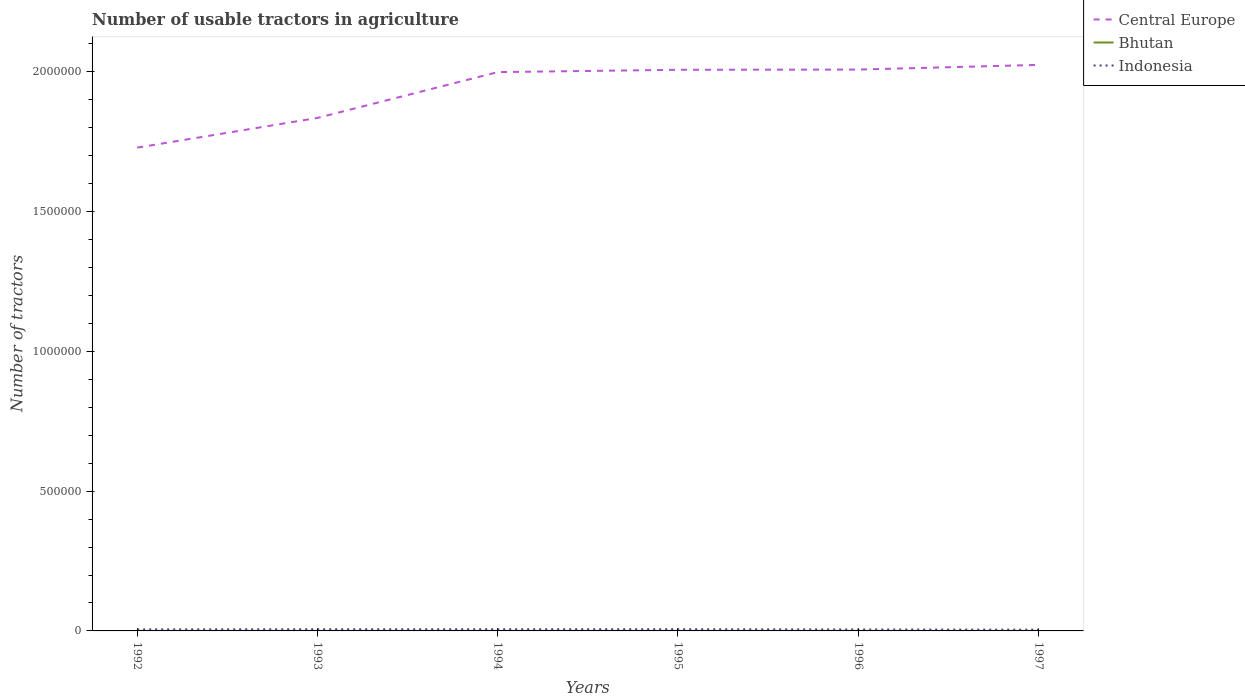How many different coloured lines are there?
Keep it short and to the point. 3. Is the number of lines equal to the number of legend labels?
Your answer should be compact. Yes. Across all years, what is the maximum number of usable tractors in agriculture in Indonesia?
Give a very brief answer. 4483. What is the total number of usable tractors in agriculture in Central Europe in the graph?
Keep it short and to the point. -1.06e+05. What is the difference between the highest and the second highest number of usable tractors in agriculture in Indonesia?
Offer a terse response. 1641. Is the number of usable tractors in agriculture in Indonesia strictly greater than the number of usable tractors in agriculture in Central Europe over the years?
Offer a very short reply. Yes. How many lines are there?
Give a very brief answer. 3. What is the title of the graph?
Make the answer very short. Number of usable tractors in agriculture. What is the label or title of the X-axis?
Offer a terse response. Years. What is the label or title of the Y-axis?
Offer a very short reply. Number of tractors. What is the Number of tractors in Central Europe in 1992?
Your answer should be compact. 1.73e+06. What is the Number of tractors in Bhutan in 1992?
Make the answer very short. 70. What is the Number of tractors of Indonesia in 1992?
Ensure brevity in your answer.  5470. What is the Number of tractors in Central Europe in 1993?
Offer a terse response. 1.83e+06. What is the Number of tractors in Indonesia in 1993?
Make the answer very short. 5942. What is the Number of tractors of Central Europe in 1994?
Your answer should be compact. 2.00e+06. What is the Number of tractors in Indonesia in 1994?
Give a very brief answer. 6033. What is the Number of tractors in Central Europe in 1995?
Your answer should be compact. 2.01e+06. What is the Number of tractors in Indonesia in 1995?
Offer a very short reply. 6124. What is the Number of tractors of Central Europe in 1996?
Offer a terse response. 2.01e+06. What is the Number of tractors of Bhutan in 1996?
Your answer should be very brief. 106. What is the Number of tractors in Indonesia in 1996?
Offer a terse response. 5139. What is the Number of tractors in Central Europe in 1997?
Your response must be concise. 2.02e+06. What is the Number of tractors of Bhutan in 1997?
Ensure brevity in your answer.  110. What is the Number of tractors of Indonesia in 1997?
Keep it short and to the point. 4483. Across all years, what is the maximum Number of tractors in Central Europe?
Offer a terse response. 2.02e+06. Across all years, what is the maximum Number of tractors in Bhutan?
Make the answer very short. 110. Across all years, what is the maximum Number of tractors in Indonesia?
Ensure brevity in your answer.  6124. Across all years, what is the minimum Number of tractors in Central Europe?
Provide a succinct answer. 1.73e+06. Across all years, what is the minimum Number of tractors in Bhutan?
Your response must be concise. 70. Across all years, what is the minimum Number of tractors of Indonesia?
Provide a short and direct response. 4483. What is the total Number of tractors of Central Europe in the graph?
Keep it short and to the point. 1.16e+07. What is the total Number of tractors in Bhutan in the graph?
Offer a terse response. 556. What is the total Number of tractors in Indonesia in the graph?
Your answer should be compact. 3.32e+04. What is the difference between the Number of tractors of Central Europe in 1992 and that in 1993?
Make the answer very short. -1.06e+05. What is the difference between the Number of tractors in Bhutan in 1992 and that in 1993?
Give a very brief answer. -10. What is the difference between the Number of tractors of Indonesia in 1992 and that in 1993?
Ensure brevity in your answer.  -472. What is the difference between the Number of tractors of Central Europe in 1992 and that in 1994?
Provide a short and direct response. -2.70e+05. What is the difference between the Number of tractors in Bhutan in 1992 and that in 1994?
Provide a succinct answer. -20. What is the difference between the Number of tractors in Indonesia in 1992 and that in 1994?
Ensure brevity in your answer.  -563. What is the difference between the Number of tractors of Central Europe in 1992 and that in 1995?
Offer a very short reply. -2.78e+05. What is the difference between the Number of tractors in Bhutan in 1992 and that in 1995?
Provide a succinct answer. -30. What is the difference between the Number of tractors in Indonesia in 1992 and that in 1995?
Your answer should be compact. -654. What is the difference between the Number of tractors of Central Europe in 1992 and that in 1996?
Give a very brief answer. -2.79e+05. What is the difference between the Number of tractors in Bhutan in 1992 and that in 1996?
Provide a short and direct response. -36. What is the difference between the Number of tractors of Indonesia in 1992 and that in 1996?
Ensure brevity in your answer.  331. What is the difference between the Number of tractors of Central Europe in 1992 and that in 1997?
Offer a very short reply. -2.96e+05. What is the difference between the Number of tractors of Indonesia in 1992 and that in 1997?
Offer a terse response. 987. What is the difference between the Number of tractors of Central Europe in 1993 and that in 1994?
Your answer should be very brief. -1.64e+05. What is the difference between the Number of tractors of Bhutan in 1993 and that in 1994?
Your answer should be compact. -10. What is the difference between the Number of tractors of Indonesia in 1993 and that in 1994?
Provide a succinct answer. -91. What is the difference between the Number of tractors of Central Europe in 1993 and that in 1995?
Your response must be concise. -1.72e+05. What is the difference between the Number of tractors of Indonesia in 1993 and that in 1995?
Keep it short and to the point. -182. What is the difference between the Number of tractors of Central Europe in 1993 and that in 1996?
Your answer should be compact. -1.73e+05. What is the difference between the Number of tractors of Bhutan in 1993 and that in 1996?
Your answer should be very brief. -26. What is the difference between the Number of tractors in Indonesia in 1993 and that in 1996?
Offer a terse response. 803. What is the difference between the Number of tractors of Central Europe in 1993 and that in 1997?
Provide a succinct answer. -1.90e+05. What is the difference between the Number of tractors of Bhutan in 1993 and that in 1997?
Give a very brief answer. -30. What is the difference between the Number of tractors of Indonesia in 1993 and that in 1997?
Ensure brevity in your answer.  1459. What is the difference between the Number of tractors of Central Europe in 1994 and that in 1995?
Ensure brevity in your answer.  -8307. What is the difference between the Number of tractors of Bhutan in 1994 and that in 1995?
Provide a succinct answer. -10. What is the difference between the Number of tractors in Indonesia in 1994 and that in 1995?
Your response must be concise. -91. What is the difference between the Number of tractors of Central Europe in 1994 and that in 1996?
Your answer should be very brief. -9091. What is the difference between the Number of tractors in Indonesia in 1994 and that in 1996?
Give a very brief answer. 894. What is the difference between the Number of tractors in Central Europe in 1994 and that in 1997?
Offer a very short reply. -2.59e+04. What is the difference between the Number of tractors in Bhutan in 1994 and that in 1997?
Your answer should be compact. -20. What is the difference between the Number of tractors in Indonesia in 1994 and that in 1997?
Provide a short and direct response. 1550. What is the difference between the Number of tractors in Central Europe in 1995 and that in 1996?
Provide a short and direct response. -784. What is the difference between the Number of tractors of Bhutan in 1995 and that in 1996?
Offer a very short reply. -6. What is the difference between the Number of tractors in Indonesia in 1995 and that in 1996?
Your answer should be compact. 985. What is the difference between the Number of tractors of Central Europe in 1995 and that in 1997?
Give a very brief answer. -1.76e+04. What is the difference between the Number of tractors in Indonesia in 1995 and that in 1997?
Give a very brief answer. 1641. What is the difference between the Number of tractors in Central Europe in 1996 and that in 1997?
Provide a succinct answer. -1.68e+04. What is the difference between the Number of tractors in Bhutan in 1996 and that in 1997?
Ensure brevity in your answer.  -4. What is the difference between the Number of tractors of Indonesia in 1996 and that in 1997?
Your answer should be very brief. 656. What is the difference between the Number of tractors in Central Europe in 1992 and the Number of tractors in Bhutan in 1993?
Offer a very short reply. 1.73e+06. What is the difference between the Number of tractors in Central Europe in 1992 and the Number of tractors in Indonesia in 1993?
Keep it short and to the point. 1.72e+06. What is the difference between the Number of tractors in Bhutan in 1992 and the Number of tractors in Indonesia in 1993?
Keep it short and to the point. -5872. What is the difference between the Number of tractors in Central Europe in 1992 and the Number of tractors in Bhutan in 1994?
Your response must be concise. 1.73e+06. What is the difference between the Number of tractors in Central Europe in 1992 and the Number of tractors in Indonesia in 1994?
Your answer should be very brief. 1.72e+06. What is the difference between the Number of tractors of Bhutan in 1992 and the Number of tractors of Indonesia in 1994?
Your answer should be very brief. -5963. What is the difference between the Number of tractors of Central Europe in 1992 and the Number of tractors of Bhutan in 1995?
Your answer should be compact. 1.73e+06. What is the difference between the Number of tractors of Central Europe in 1992 and the Number of tractors of Indonesia in 1995?
Your answer should be very brief. 1.72e+06. What is the difference between the Number of tractors in Bhutan in 1992 and the Number of tractors in Indonesia in 1995?
Make the answer very short. -6054. What is the difference between the Number of tractors of Central Europe in 1992 and the Number of tractors of Bhutan in 1996?
Your response must be concise. 1.73e+06. What is the difference between the Number of tractors in Central Europe in 1992 and the Number of tractors in Indonesia in 1996?
Your response must be concise. 1.72e+06. What is the difference between the Number of tractors of Bhutan in 1992 and the Number of tractors of Indonesia in 1996?
Make the answer very short. -5069. What is the difference between the Number of tractors of Central Europe in 1992 and the Number of tractors of Bhutan in 1997?
Keep it short and to the point. 1.73e+06. What is the difference between the Number of tractors of Central Europe in 1992 and the Number of tractors of Indonesia in 1997?
Your response must be concise. 1.72e+06. What is the difference between the Number of tractors in Bhutan in 1992 and the Number of tractors in Indonesia in 1997?
Give a very brief answer. -4413. What is the difference between the Number of tractors in Central Europe in 1993 and the Number of tractors in Bhutan in 1994?
Ensure brevity in your answer.  1.83e+06. What is the difference between the Number of tractors of Central Europe in 1993 and the Number of tractors of Indonesia in 1994?
Give a very brief answer. 1.83e+06. What is the difference between the Number of tractors in Bhutan in 1993 and the Number of tractors in Indonesia in 1994?
Your response must be concise. -5953. What is the difference between the Number of tractors of Central Europe in 1993 and the Number of tractors of Bhutan in 1995?
Make the answer very short. 1.83e+06. What is the difference between the Number of tractors of Central Europe in 1993 and the Number of tractors of Indonesia in 1995?
Provide a short and direct response. 1.83e+06. What is the difference between the Number of tractors of Bhutan in 1993 and the Number of tractors of Indonesia in 1995?
Your response must be concise. -6044. What is the difference between the Number of tractors of Central Europe in 1993 and the Number of tractors of Bhutan in 1996?
Your response must be concise. 1.83e+06. What is the difference between the Number of tractors of Central Europe in 1993 and the Number of tractors of Indonesia in 1996?
Your answer should be very brief. 1.83e+06. What is the difference between the Number of tractors of Bhutan in 1993 and the Number of tractors of Indonesia in 1996?
Ensure brevity in your answer.  -5059. What is the difference between the Number of tractors in Central Europe in 1993 and the Number of tractors in Bhutan in 1997?
Offer a terse response. 1.83e+06. What is the difference between the Number of tractors of Central Europe in 1993 and the Number of tractors of Indonesia in 1997?
Give a very brief answer. 1.83e+06. What is the difference between the Number of tractors of Bhutan in 1993 and the Number of tractors of Indonesia in 1997?
Offer a very short reply. -4403. What is the difference between the Number of tractors of Central Europe in 1994 and the Number of tractors of Bhutan in 1995?
Your answer should be compact. 2.00e+06. What is the difference between the Number of tractors of Central Europe in 1994 and the Number of tractors of Indonesia in 1995?
Your answer should be very brief. 1.99e+06. What is the difference between the Number of tractors of Bhutan in 1994 and the Number of tractors of Indonesia in 1995?
Give a very brief answer. -6034. What is the difference between the Number of tractors of Central Europe in 1994 and the Number of tractors of Bhutan in 1996?
Make the answer very short. 2.00e+06. What is the difference between the Number of tractors in Central Europe in 1994 and the Number of tractors in Indonesia in 1996?
Your response must be concise. 1.99e+06. What is the difference between the Number of tractors of Bhutan in 1994 and the Number of tractors of Indonesia in 1996?
Your response must be concise. -5049. What is the difference between the Number of tractors in Central Europe in 1994 and the Number of tractors in Bhutan in 1997?
Your response must be concise. 2.00e+06. What is the difference between the Number of tractors of Central Europe in 1994 and the Number of tractors of Indonesia in 1997?
Your response must be concise. 1.99e+06. What is the difference between the Number of tractors of Bhutan in 1994 and the Number of tractors of Indonesia in 1997?
Offer a very short reply. -4393. What is the difference between the Number of tractors of Central Europe in 1995 and the Number of tractors of Bhutan in 1996?
Provide a succinct answer. 2.01e+06. What is the difference between the Number of tractors of Central Europe in 1995 and the Number of tractors of Indonesia in 1996?
Keep it short and to the point. 2.00e+06. What is the difference between the Number of tractors of Bhutan in 1995 and the Number of tractors of Indonesia in 1996?
Your answer should be very brief. -5039. What is the difference between the Number of tractors in Central Europe in 1995 and the Number of tractors in Bhutan in 1997?
Offer a very short reply. 2.01e+06. What is the difference between the Number of tractors of Central Europe in 1995 and the Number of tractors of Indonesia in 1997?
Your answer should be compact. 2.00e+06. What is the difference between the Number of tractors of Bhutan in 1995 and the Number of tractors of Indonesia in 1997?
Offer a very short reply. -4383. What is the difference between the Number of tractors of Central Europe in 1996 and the Number of tractors of Bhutan in 1997?
Offer a very short reply. 2.01e+06. What is the difference between the Number of tractors of Central Europe in 1996 and the Number of tractors of Indonesia in 1997?
Ensure brevity in your answer.  2.00e+06. What is the difference between the Number of tractors in Bhutan in 1996 and the Number of tractors in Indonesia in 1997?
Your response must be concise. -4377. What is the average Number of tractors of Central Europe per year?
Provide a succinct answer. 1.93e+06. What is the average Number of tractors of Bhutan per year?
Your answer should be compact. 92.67. What is the average Number of tractors of Indonesia per year?
Make the answer very short. 5531.83. In the year 1992, what is the difference between the Number of tractors of Central Europe and Number of tractors of Bhutan?
Offer a terse response. 1.73e+06. In the year 1992, what is the difference between the Number of tractors in Central Europe and Number of tractors in Indonesia?
Offer a terse response. 1.72e+06. In the year 1992, what is the difference between the Number of tractors in Bhutan and Number of tractors in Indonesia?
Offer a very short reply. -5400. In the year 1993, what is the difference between the Number of tractors of Central Europe and Number of tractors of Bhutan?
Ensure brevity in your answer.  1.83e+06. In the year 1993, what is the difference between the Number of tractors in Central Europe and Number of tractors in Indonesia?
Your response must be concise. 1.83e+06. In the year 1993, what is the difference between the Number of tractors of Bhutan and Number of tractors of Indonesia?
Offer a very short reply. -5862. In the year 1994, what is the difference between the Number of tractors in Central Europe and Number of tractors in Bhutan?
Offer a terse response. 2.00e+06. In the year 1994, what is the difference between the Number of tractors of Central Europe and Number of tractors of Indonesia?
Give a very brief answer. 1.99e+06. In the year 1994, what is the difference between the Number of tractors of Bhutan and Number of tractors of Indonesia?
Offer a very short reply. -5943. In the year 1995, what is the difference between the Number of tractors in Central Europe and Number of tractors in Bhutan?
Your response must be concise. 2.01e+06. In the year 1995, what is the difference between the Number of tractors of Central Europe and Number of tractors of Indonesia?
Your response must be concise. 2.00e+06. In the year 1995, what is the difference between the Number of tractors in Bhutan and Number of tractors in Indonesia?
Keep it short and to the point. -6024. In the year 1996, what is the difference between the Number of tractors of Central Europe and Number of tractors of Bhutan?
Your answer should be very brief. 2.01e+06. In the year 1996, what is the difference between the Number of tractors of Central Europe and Number of tractors of Indonesia?
Provide a short and direct response. 2.00e+06. In the year 1996, what is the difference between the Number of tractors of Bhutan and Number of tractors of Indonesia?
Your answer should be compact. -5033. In the year 1997, what is the difference between the Number of tractors of Central Europe and Number of tractors of Bhutan?
Offer a terse response. 2.02e+06. In the year 1997, what is the difference between the Number of tractors of Central Europe and Number of tractors of Indonesia?
Keep it short and to the point. 2.02e+06. In the year 1997, what is the difference between the Number of tractors in Bhutan and Number of tractors in Indonesia?
Keep it short and to the point. -4373. What is the ratio of the Number of tractors of Central Europe in 1992 to that in 1993?
Your answer should be very brief. 0.94. What is the ratio of the Number of tractors of Bhutan in 1992 to that in 1993?
Keep it short and to the point. 0.88. What is the ratio of the Number of tractors in Indonesia in 1992 to that in 1993?
Provide a succinct answer. 0.92. What is the ratio of the Number of tractors of Central Europe in 1992 to that in 1994?
Offer a very short reply. 0.86. What is the ratio of the Number of tractors of Bhutan in 1992 to that in 1994?
Offer a terse response. 0.78. What is the ratio of the Number of tractors in Indonesia in 1992 to that in 1994?
Keep it short and to the point. 0.91. What is the ratio of the Number of tractors of Central Europe in 1992 to that in 1995?
Ensure brevity in your answer.  0.86. What is the ratio of the Number of tractors of Bhutan in 1992 to that in 1995?
Make the answer very short. 0.7. What is the ratio of the Number of tractors of Indonesia in 1992 to that in 1995?
Ensure brevity in your answer.  0.89. What is the ratio of the Number of tractors of Central Europe in 1992 to that in 1996?
Ensure brevity in your answer.  0.86. What is the ratio of the Number of tractors in Bhutan in 1992 to that in 1996?
Your answer should be compact. 0.66. What is the ratio of the Number of tractors of Indonesia in 1992 to that in 1996?
Your response must be concise. 1.06. What is the ratio of the Number of tractors of Central Europe in 1992 to that in 1997?
Your answer should be compact. 0.85. What is the ratio of the Number of tractors in Bhutan in 1992 to that in 1997?
Offer a terse response. 0.64. What is the ratio of the Number of tractors of Indonesia in 1992 to that in 1997?
Provide a succinct answer. 1.22. What is the ratio of the Number of tractors of Central Europe in 1993 to that in 1994?
Give a very brief answer. 0.92. What is the ratio of the Number of tractors of Indonesia in 1993 to that in 1994?
Provide a short and direct response. 0.98. What is the ratio of the Number of tractors of Central Europe in 1993 to that in 1995?
Your answer should be compact. 0.91. What is the ratio of the Number of tractors in Bhutan in 1993 to that in 1995?
Your answer should be very brief. 0.8. What is the ratio of the Number of tractors of Indonesia in 1993 to that in 1995?
Provide a short and direct response. 0.97. What is the ratio of the Number of tractors of Central Europe in 1993 to that in 1996?
Provide a succinct answer. 0.91. What is the ratio of the Number of tractors in Bhutan in 1993 to that in 1996?
Keep it short and to the point. 0.75. What is the ratio of the Number of tractors of Indonesia in 1993 to that in 1996?
Offer a very short reply. 1.16. What is the ratio of the Number of tractors of Central Europe in 1993 to that in 1997?
Provide a succinct answer. 0.91. What is the ratio of the Number of tractors of Bhutan in 1993 to that in 1997?
Offer a terse response. 0.73. What is the ratio of the Number of tractors of Indonesia in 1993 to that in 1997?
Keep it short and to the point. 1.33. What is the ratio of the Number of tractors of Bhutan in 1994 to that in 1995?
Ensure brevity in your answer.  0.9. What is the ratio of the Number of tractors in Indonesia in 1994 to that in 1995?
Offer a terse response. 0.99. What is the ratio of the Number of tractors in Bhutan in 1994 to that in 1996?
Your answer should be compact. 0.85. What is the ratio of the Number of tractors in Indonesia in 1994 to that in 1996?
Provide a short and direct response. 1.17. What is the ratio of the Number of tractors of Central Europe in 1994 to that in 1997?
Ensure brevity in your answer.  0.99. What is the ratio of the Number of tractors in Bhutan in 1994 to that in 1997?
Offer a terse response. 0.82. What is the ratio of the Number of tractors in Indonesia in 1994 to that in 1997?
Provide a short and direct response. 1.35. What is the ratio of the Number of tractors of Central Europe in 1995 to that in 1996?
Your response must be concise. 1. What is the ratio of the Number of tractors in Bhutan in 1995 to that in 1996?
Offer a very short reply. 0.94. What is the ratio of the Number of tractors in Indonesia in 1995 to that in 1996?
Your answer should be compact. 1.19. What is the ratio of the Number of tractors in Indonesia in 1995 to that in 1997?
Offer a very short reply. 1.37. What is the ratio of the Number of tractors of Bhutan in 1996 to that in 1997?
Ensure brevity in your answer.  0.96. What is the ratio of the Number of tractors in Indonesia in 1996 to that in 1997?
Offer a very short reply. 1.15. What is the difference between the highest and the second highest Number of tractors of Central Europe?
Provide a short and direct response. 1.68e+04. What is the difference between the highest and the second highest Number of tractors of Bhutan?
Ensure brevity in your answer.  4. What is the difference between the highest and the second highest Number of tractors of Indonesia?
Provide a succinct answer. 91. What is the difference between the highest and the lowest Number of tractors in Central Europe?
Your answer should be very brief. 2.96e+05. What is the difference between the highest and the lowest Number of tractors of Bhutan?
Provide a succinct answer. 40. What is the difference between the highest and the lowest Number of tractors of Indonesia?
Give a very brief answer. 1641. 